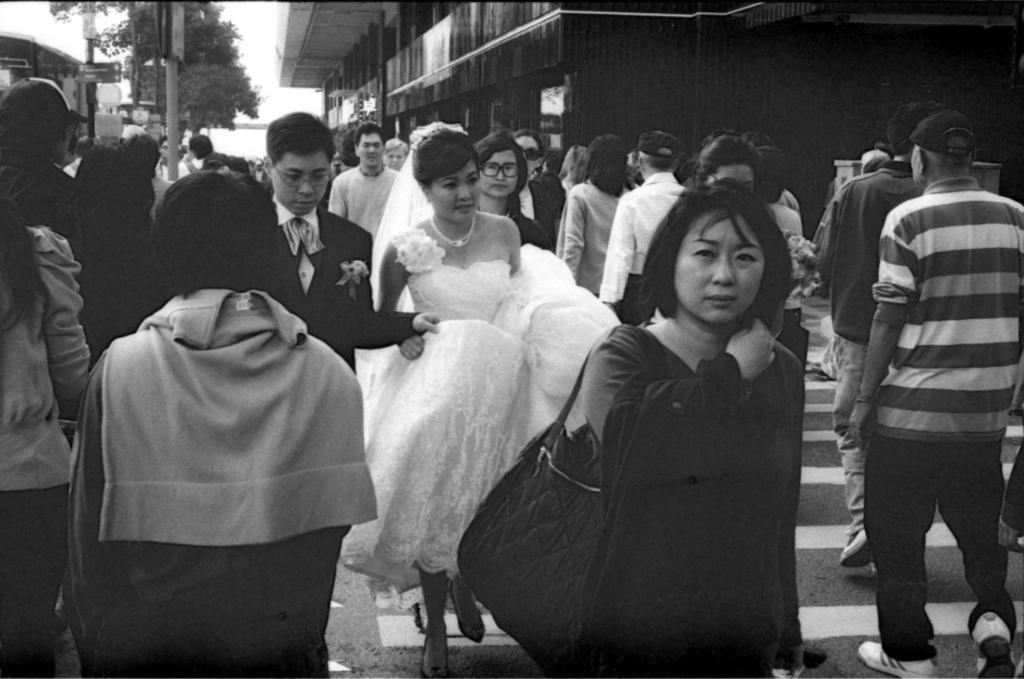Could you give a brief overview of what you see in this image? This is a black and white image. In this image we can see people walking on the road. In the background there are buildings, trees, poles and sky. 